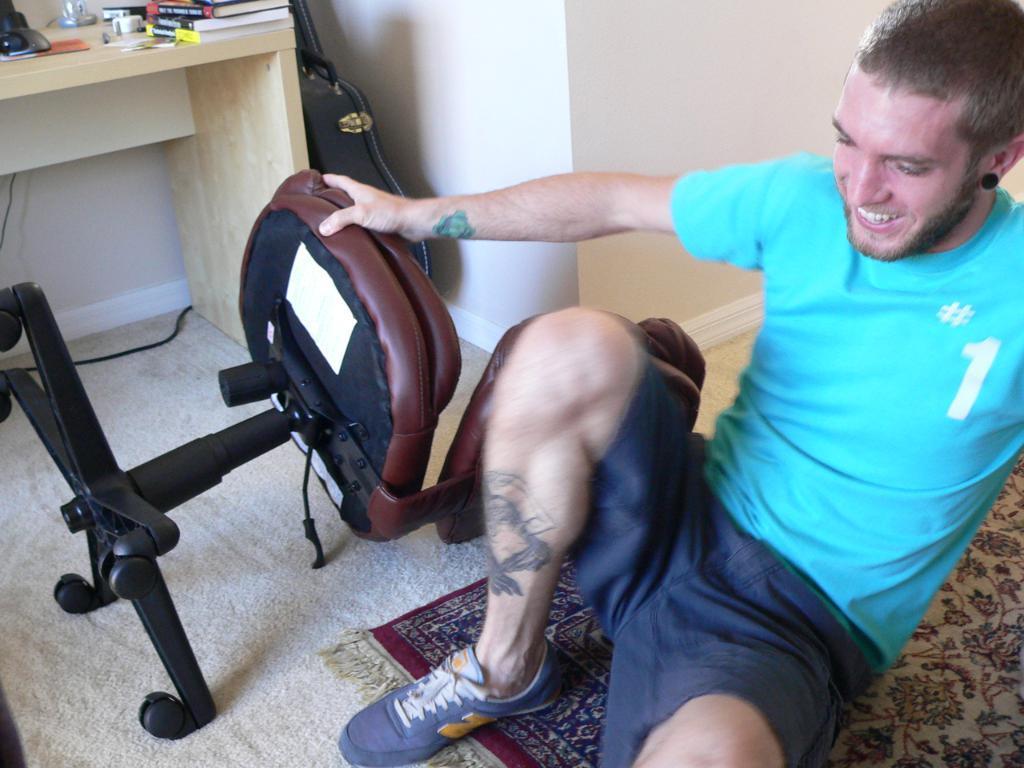How would you summarize this image in a sentence or two? There is a man. He is laughing. In the background, this is wall, this is the table. This chair is fallen. This is a mat. This is a carpet. This man is wearing a shoe, blue color T-Shirt and a short. 